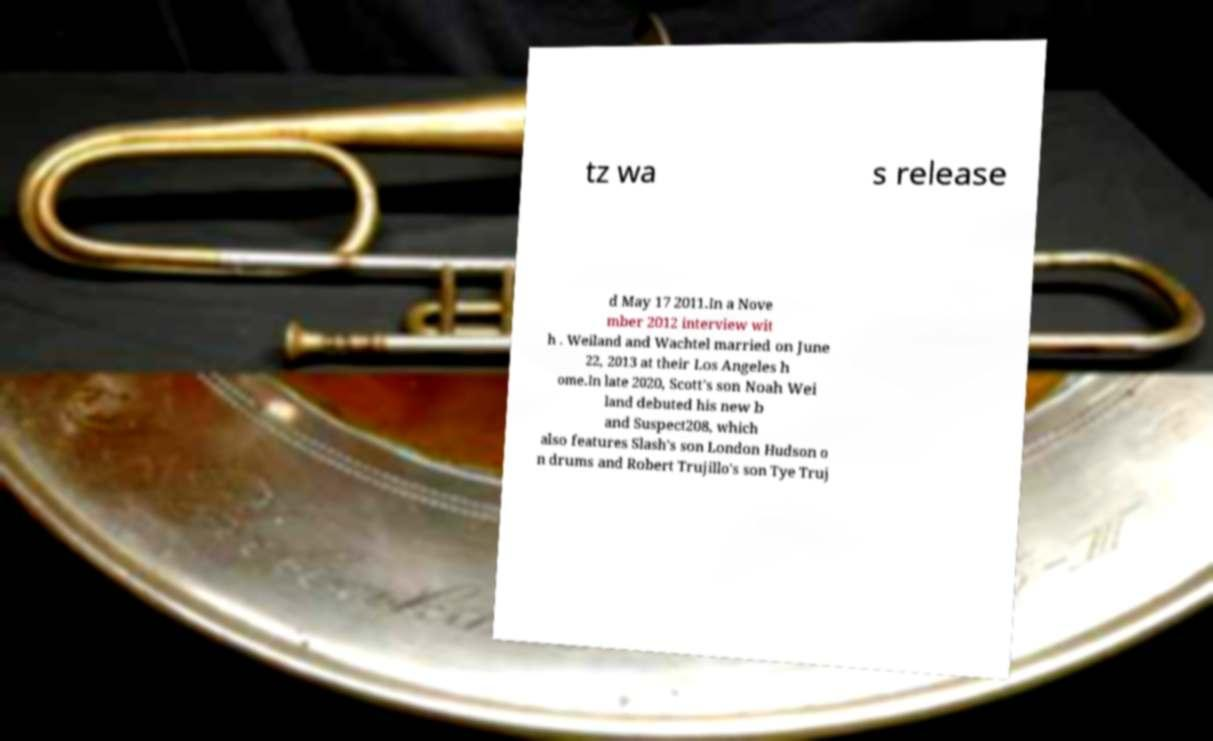I need the written content from this picture converted into text. Can you do that? tz wa s release d May 17 2011.In a Nove mber 2012 interview wit h . Weiland and Wachtel married on June 22, 2013 at their Los Angeles h ome.In late 2020, Scott's son Noah Wei land debuted his new b and Suspect208, which also features Slash's son London Hudson o n drums and Robert Trujillo's son Tye Truj 